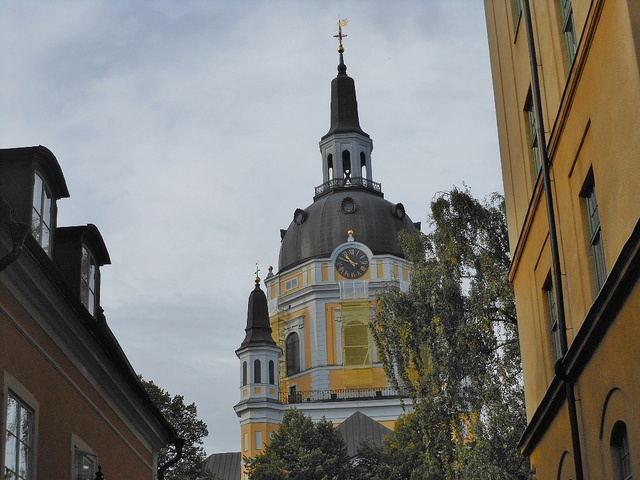Describe the objects in this image and their specific colors. I can see a clock in darkgray, gray, and black tones in this image. 